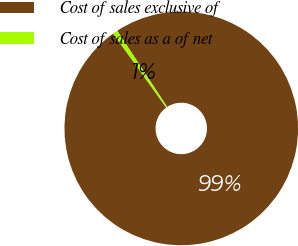Convert chart to OTSL. <chart><loc_0><loc_0><loc_500><loc_500><pie_chart><fcel>Cost of sales exclusive of<fcel>Cost of sales as a of net<nl><fcel>99.33%<fcel>0.67%<nl></chart> 